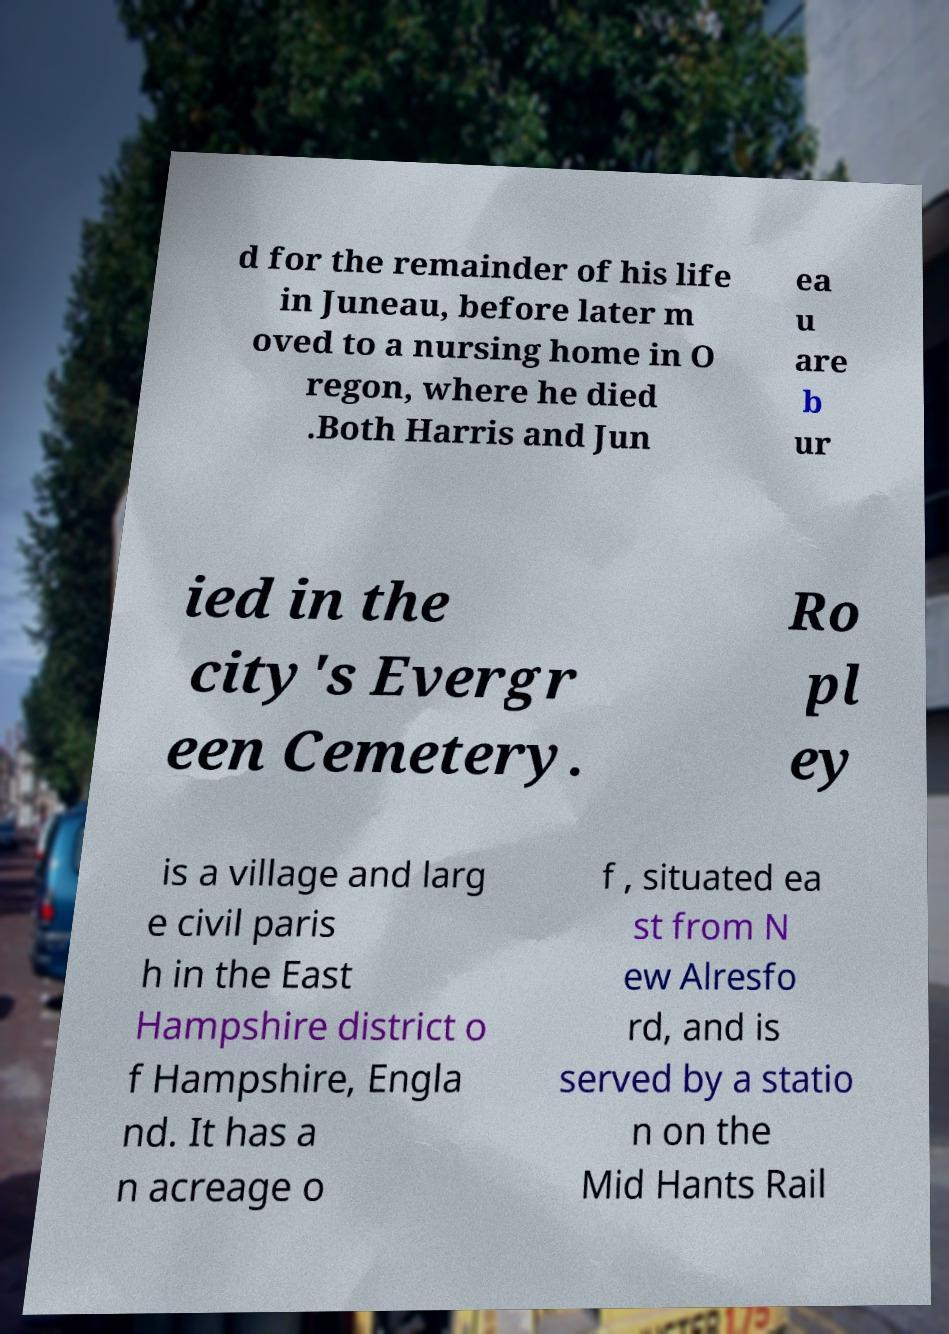I need the written content from this picture converted into text. Can you do that? d for the remainder of his life in Juneau, before later m oved to a nursing home in O regon, where he died .Both Harris and Jun ea u are b ur ied in the city's Evergr een Cemetery. Ro pl ey is a village and larg e civil paris h in the East Hampshire district o f Hampshire, Engla nd. It has a n acreage o f , situated ea st from N ew Alresfo rd, and is served by a statio n on the Mid Hants Rail 